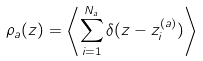<formula> <loc_0><loc_0><loc_500><loc_500>\rho _ { a } ( z ) = \left \langle \sum _ { i = 1 } ^ { N _ { a } } \delta ( z - z ^ { ( a ) } _ { i } ) \right \rangle</formula> 